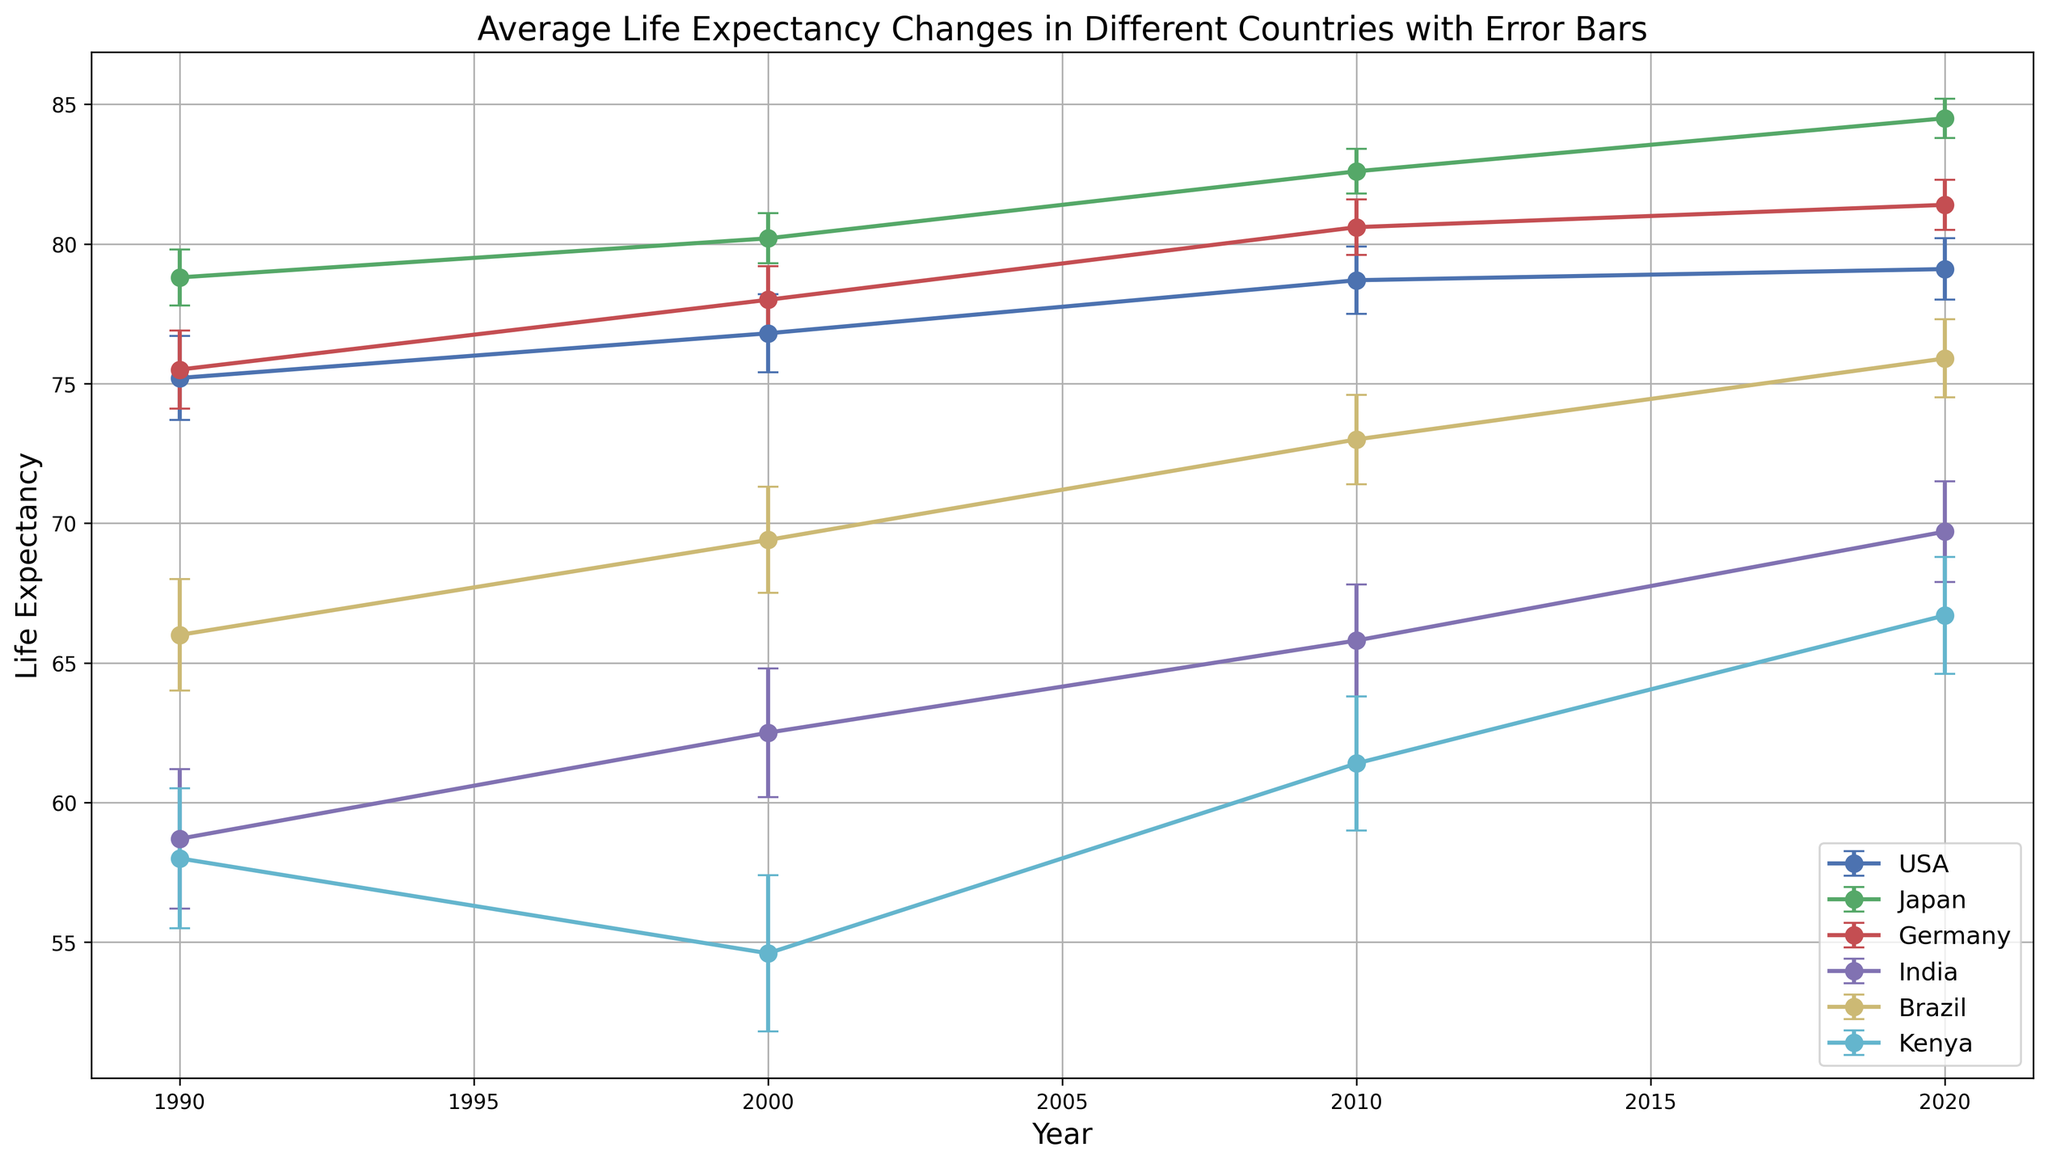What is the range of life expectancy for Japan from 1990 to 2020? To find the range, subtract the smallest life expectancy from the largest within the given years for Japan. The smallest value is 78.8 (1990) and the largest is 84.5 (2020). Therefore, the range is 84.5 - 78.8.
Answer: 5.7 Which country shows the largest increase in life expectancy from 1990 to 2020? To determine this, compare the difference in life expectancy between 1990 and 2020 for each country. The differences are: USA: 79.1 - 75.2 = 3.9, Japan: 84.5 - 78.8 = 5.7, Germany: 81.4 - 75.5 = 5.9, India: 69.7 - 58.7 = 11.0, Brazil: 75.9 - 66.0 = 9.9, Kenya: 66.7 - 58.0 = 8.7. India has the largest increase.
Answer: India Between which pair of countries is the gap in life expectancy the smallest in 2020? Inspect the life expectancy values for 2020 for all countries: USA: 79.1, Japan: 84.5, Germany: 81.4, India: 69.7, Brazil: 75.9, Kenya: 66.7. Compare these values to find the smallest difference. The smallest gap is between USA and Germany, with a difference of 81.4 - 79.1.
Answer: USA and Germany Which country had a decrease in life expectancy between 1990 and 2000? Look for a country where the data points for 1990 and 2000 show a decline in life expectancy. The only country with a decline is Kenya (58.0 in 1990 to 54.6 in 2000).
Answer: Kenya In which year did Germany’s life expectancy first surpass 80 years? Review the data points for Germany's life expectancy across years. The value surpasses 80 in 2010, where it is 80.6.
Answer: 2010 How does life expectancy growth from 1990 to 2020 compare between USA and Germany? Calculate the growth for both countries from 1990 to 2020: USA: 79.1 - 75.2 = 3.9, Germany: 81.4 - 75.5 = 5.9. Germany’s growth is higher than USA’s.
Answer: Germany's growth is higher What is the error bar range of life expectancy for India in 2010? The error bar range can be found by adding and subtracting the error value from the life expectancy. For India in 2010, it is 65.8 ± 2.0. So, the range is 63.8 to 67.8.
Answer: 63.8 to 67.8 Which country's life expectancy showed the most steady growth without any decline from 1990 to 2020? Review the trend lines in the figure for continuous upward movement without drops. Japan, Germany, India, Brazil, and the USA all show steady growth, but only Japan shows no decline at any point.
Answer: Japan In what year does Brazil’s life expectancy reach closer to 70 years? Locate the data point for Brazil where the life expectancy crosses near 70 years. In 2000 it is 69.4, and in 2010 it is 73.0. So, it first reaches closer to 70 in 2000.
Answer: 2000 